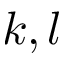Convert formula to latex. <formula><loc_0><loc_0><loc_500><loc_500>k , l</formula> 